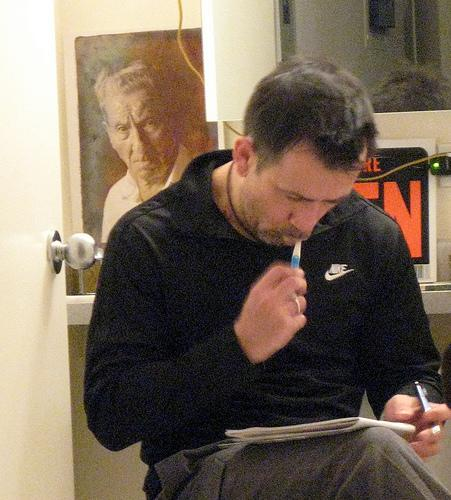Question: how many men are in the room?
Choices:
A. Two.
B. Thre.
C. Four.
D. One.
Answer with the letter. Answer: D Question: where is the pen?
Choices:
A. On the table.
B. In the man's hand.
C. In the man's pocket.
D. On the desk.
Answer with the letter. Answer: B Question: who invented nike?
Choices:
A. A man.
B. Philip knight.
C. An entrepreneur.
D. Bill Bowerman.
Answer with the letter. Answer: B 